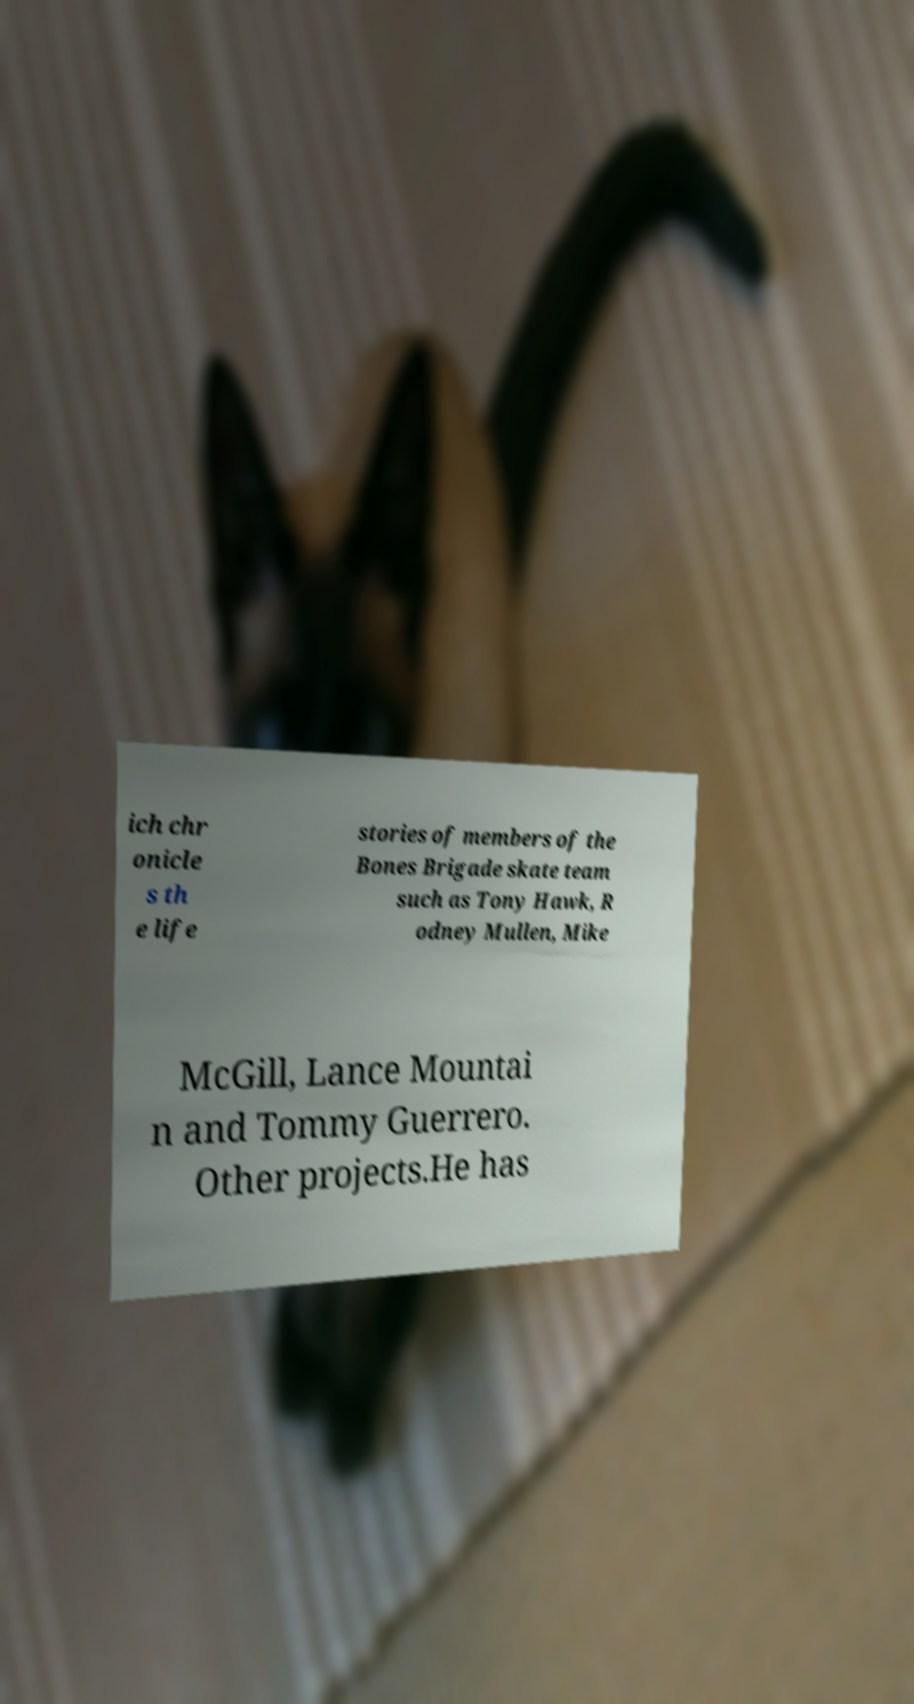I need the written content from this picture converted into text. Can you do that? ich chr onicle s th e life stories of members of the Bones Brigade skate team such as Tony Hawk, R odney Mullen, Mike McGill, Lance Mountai n and Tommy Guerrero. Other projects.He has 